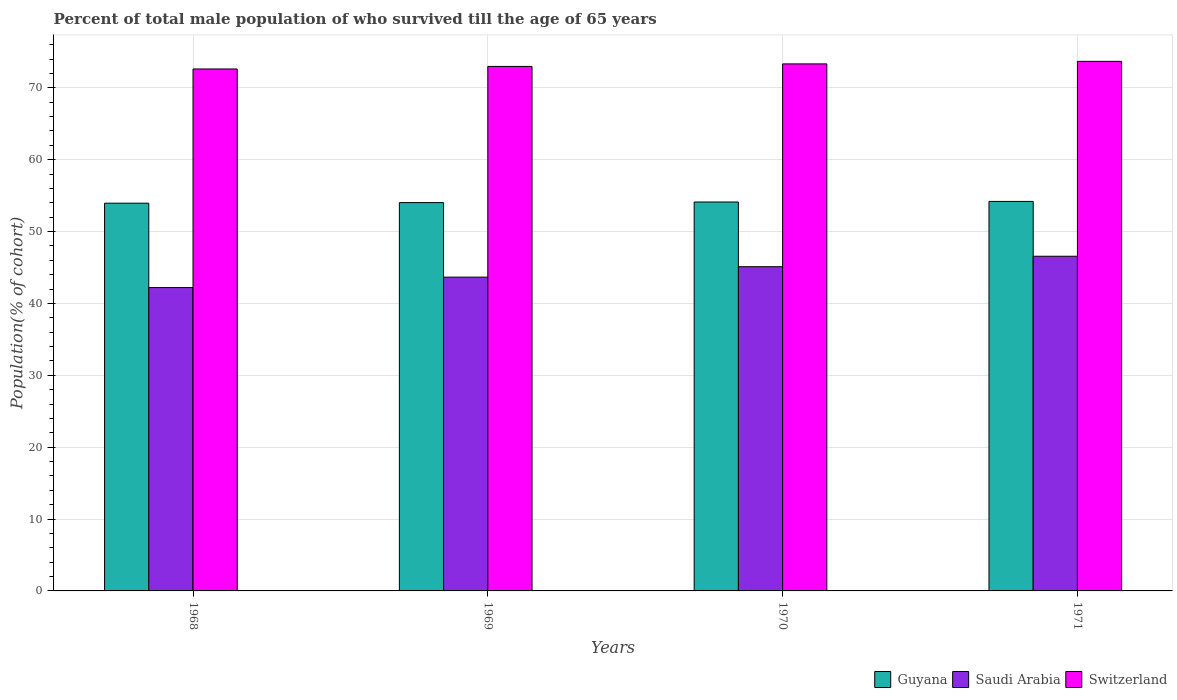Are the number of bars per tick equal to the number of legend labels?
Provide a short and direct response. Yes. Are the number of bars on each tick of the X-axis equal?
Keep it short and to the point. Yes. What is the label of the 2nd group of bars from the left?
Give a very brief answer. 1969. In how many cases, is the number of bars for a given year not equal to the number of legend labels?
Ensure brevity in your answer.  0. What is the percentage of total male population who survived till the age of 65 years in Switzerland in 1971?
Provide a succinct answer. 73.69. Across all years, what is the maximum percentage of total male population who survived till the age of 65 years in Switzerland?
Keep it short and to the point. 73.69. Across all years, what is the minimum percentage of total male population who survived till the age of 65 years in Guyana?
Your answer should be compact. 53.95. In which year was the percentage of total male population who survived till the age of 65 years in Switzerland maximum?
Ensure brevity in your answer.  1971. In which year was the percentage of total male population who survived till the age of 65 years in Switzerland minimum?
Provide a short and direct response. 1968. What is the total percentage of total male population who survived till the age of 65 years in Switzerland in the graph?
Keep it short and to the point. 292.64. What is the difference between the percentage of total male population who survived till the age of 65 years in Guyana in 1969 and that in 1970?
Provide a short and direct response. -0.08. What is the difference between the percentage of total male population who survived till the age of 65 years in Switzerland in 1968 and the percentage of total male population who survived till the age of 65 years in Saudi Arabia in 1969?
Provide a succinct answer. 28.97. What is the average percentage of total male population who survived till the age of 65 years in Guyana per year?
Offer a very short reply. 54.08. In the year 1969, what is the difference between the percentage of total male population who survived till the age of 65 years in Switzerland and percentage of total male population who survived till the age of 65 years in Guyana?
Give a very brief answer. 18.95. What is the ratio of the percentage of total male population who survived till the age of 65 years in Switzerland in 1968 to that in 1969?
Your answer should be compact. 1. Is the difference between the percentage of total male population who survived till the age of 65 years in Switzerland in 1968 and 1970 greater than the difference between the percentage of total male population who survived till the age of 65 years in Guyana in 1968 and 1970?
Provide a short and direct response. No. What is the difference between the highest and the second highest percentage of total male population who survived till the age of 65 years in Switzerland?
Your response must be concise. 0.35. What is the difference between the highest and the lowest percentage of total male population who survived till the age of 65 years in Guyana?
Your answer should be very brief. 0.25. In how many years, is the percentage of total male population who survived till the age of 65 years in Guyana greater than the average percentage of total male population who survived till the age of 65 years in Guyana taken over all years?
Make the answer very short. 2. What does the 1st bar from the left in 1970 represents?
Make the answer very short. Guyana. What does the 2nd bar from the right in 1968 represents?
Ensure brevity in your answer.  Saudi Arabia. How many bars are there?
Provide a succinct answer. 12. Are all the bars in the graph horizontal?
Make the answer very short. No. Are the values on the major ticks of Y-axis written in scientific E-notation?
Give a very brief answer. No. Does the graph contain any zero values?
Offer a very short reply. No. Does the graph contain grids?
Your answer should be compact. Yes. How many legend labels are there?
Ensure brevity in your answer.  3. What is the title of the graph?
Your response must be concise. Percent of total male population of who survived till the age of 65 years. What is the label or title of the X-axis?
Offer a very short reply. Years. What is the label or title of the Y-axis?
Your response must be concise. Population(% of cohort). What is the Population(% of cohort) of Guyana in 1968?
Ensure brevity in your answer.  53.95. What is the Population(% of cohort) in Saudi Arabia in 1968?
Your response must be concise. 42.21. What is the Population(% of cohort) of Switzerland in 1968?
Make the answer very short. 72.63. What is the Population(% of cohort) in Guyana in 1969?
Offer a very short reply. 54.04. What is the Population(% of cohort) in Saudi Arabia in 1969?
Ensure brevity in your answer.  43.66. What is the Population(% of cohort) in Switzerland in 1969?
Offer a terse response. 72.98. What is the Population(% of cohort) of Guyana in 1970?
Give a very brief answer. 54.12. What is the Population(% of cohort) of Saudi Arabia in 1970?
Give a very brief answer. 45.12. What is the Population(% of cohort) in Switzerland in 1970?
Provide a short and direct response. 73.34. What is the Population(% of cohort) of Guyana in 1971?
Ensure brevity in your answer.  54.2. What is the Population(% of cohort) in Saudi Arabia in 1971?
Offer a very short reply. 46.57. What is the Population(% of cohort) in Switzerland in 1971?
Offer a terse response. 73.69. Across all years, what is the maximum Population(% of cohort) of Guyana?
Your answer should be compact. 54.2. Across all years, what is the maximum Population(% of cohort) of Saudi Arabia?
Give a very brief answer. 46.57. Across all years, what is the maximum Population(% of cohort) of Switzerland?
Provide a short and direct response. 73.69. Across all years, what is the minimum Population(% of cohort) of Guyana?
Offer a terse response. 53.95. Across all years, what is the minimum Population(% of cohort) of Saudi Arabia?
Your response must be concise. 42.21. Across all years, what is the minimum Population(% of cohort) in Switzerland?
Your response must be concise. 72.63. What is the total Population(% of cohort) of Guyana in the graph?
Keep it short and to the point. 216.31. What is the total Population(% of cohort) in Saudi Arabia in the graph?
Your answer should be very brief. 177.56. What is the total Population(% of cohort) in Switzerland in the graph?
Give a very brief answer. 292.64. What is the difference between the Population(% of cohort) in Guyana in 1968 and that in 1969?
Your response must be concise. -0.08. What is the difference between the Population(% of cohort) in Saudi Arabia in 1968 and that in 1969?
Offer a very short reply. -1.45. What is the difference between the Population(% of cohort) in Switzerland in 1968 and that in 1969?
Offer a very short reply. -0.35. What is the difference between the Population(% of cohort) in Guyana in 1968 and that in 1970?
Ensure brevity in your answer.  -0.16. What is the difference between the Population(% of cohort) in Saudi Arabia in 1968 and that in 1970?
Keep it short and to the point. -2.91. What is the difference between the Population(% of cohort) in Switzerland in 1968 and that in 1970?
Offer a very short reply. -0.71. What is the difference between the Population(% of cohort) in Guyana in 1968 and that in 1971?
Your answer should be compact. -0.24. What is the difference between the Population(% of cohort) in Saudi Arabia in 1968 and that in 1971?
Offer a very short reply. -4.36. What is the difference between the Population(% of cohort) in Switzerland in 1968 and that in 1971?
Your answer should be compact. -1.06. What is the difference between the Population(% of cohort) of Guyana in 1969 and that in 1970?
Your answer should be very brief. -0.08. What is the difference between the Population(% of cohort) of Saudi Arabia in 1969 and that in 1970?
Provide a short and direct response. -1.45. What is the difference between the Population(% of cohort) of Switzerland in 1969 and that in 1970?
Your answer should be very brief. -0.35. What is the difference between the Population(% of cohort) of Guyana in 1969 and that in 1971?
Give a very brief answer. -0.16. What is the difference between the Population(% of cohort) of Saudi Arabia in 1969 and that in 1971?
Provide a short and direct response. -2.91. What is the difference between the Population(% of cohort) of Switzerland in 1969 and that in 1971?
Make the answer very short. -0.71. What is the difference between the Population(% of cohort) of Guyana in 1970 and that in 1971?
Offer a terse response. -0.08. What is the difference between the Population(% of cohort) of Saudi Arabia in 1970 and that in 1971?
Provide a succinct answer. -1.45. What is the difference between the Population(% of cohort) of Switzerland in 1970 and that in 1971?
Give a very brief answer. -0.35. What is the difference between the Population(% of cohort) in Guyana in 1968 and the Population(% of cohort) in Saudi Arabia in 1969?
Give a very brief answer. 10.29. What is the difference between the Population(% of cohort) in Guyana in 1968 and the Population(% of cohort) in Switzerland in 1969?
Offer a very short reply. -19.03. What is the difference between the Population(% of cohort) in Saudi Arabia in 1968 and the Population(% of cohort) in Switzerland in 1969?
Keep it short and to the point. -30.77. What is the difference between the Population(% of cohort) in Guyana in 1968 and the Population(% of cohort) in Saudi Arabia in 1970?
Offer a terse response. 8.84. What is the difference between the Population(% of cohort) in Guyana in 1968 and the Population(% of cohort) in Switzerland in 1970?
Your answer should be compact. -19.38. What is the difference between the Population(% of cohort) of Saudi Arabia in 1968 and the Population(% of cohort) of Switzerland in 1970?
Provide a succinct answer. -31.13. What is the difference between the Population(% of cohort) in Guyana in 1968 and the Population(% of cohort) in Saudi Arabia in 1971?
Make the answer very short. 7.38. What is the difference between the Population(% of cohort) in Guyana in 1968 and the Population(% of cohort) in Switzerland in 1971?
Provide a short and direct response. -19.74. What is the difference between the Population(% of cohort) in Saudi Arabia in 1968 and the Population(% of cohort) in Switzerland in 1971?
Your answer should be compact. -31.48. What is the difference between the Population(% of cohort) of Guyana in 1969 and the Population(% of cohort) of Saudi Arabia in 1970?
Your response must be concise. 8.92. What is the difference between the Population(% of cohort) of Guyana in 1969 and the Population(% of cohort) of Switzerland in 1970?
Ensure brevity in your answer.  -19.3. What is the difference between the Population(% of cohort) of Saudi Arabia in 1969 and the Population(% of cohort) of Switzerland in 1970?
Provide a short and direct response. -29.67. What is the difference between the Population(% of cohort) of Guyana in 1969 and the Population(% of cohort) of Saudi Arabia in 1971?
Provide a succinct answer. 7.47. What is the difference between the Population(% of cohort) of Guyana in 1969 and the Population(% of cohort) of Switzerland in 1971?
Your answer should be compact. -19.65. What is the difference between the Population(% of cohort) in Saudi Arabia in 1969 and the Population(% of cohort) in Switzerland in 1971?
Your answer should be compact. -30.03. What is the difference between the Population(% of cohort) of Guyana in 1970 and the Population(% of cohort) of Saudi Arabia in 1971?
Provide a short and direct response. 7.55. What is the difference between the Population(% of cohort) in Guyana in 1970 and the Population(% of cohort) in Switzerland in 1971?
Your answer should be very brief. -19.57. What is the difference between the Population(% of cohort) of Saudi Arabia in 1970 and the Population(% of cohort) of Switzerland in 1971?
Provide a short and direct response. -28.57. What is the average Population(% of cohort) in Guyana per year?
Your response must be concise. 54.08. What is the average Population(% of cohort) of Saudi Arabia per year?
Give a very brief answer. 44.39. What is the average Population(% of cohort) in Switzerland per year?
Ensure brevity in your answer.  73.16. In the year 1968, what is the difference between the Population(% of cohort) in Guyana and Population(% of cohort) in Saudi Arabia?
Make the answer very short. 11.74. In the year 1968, what is the difference between the Population(% of cohort) in Guyana and Population(% of cohort) in Switzerland?
Offer a terse response. -18.67. In the year 1968, what is the difference between the Population(% of cohort) of Saudi Arabia and Population(% of cohort) of Switzerland?
Offer a very short reply. -30.42. In the year 1969, what is the difference between the Population(% of cohort) in Guyana and Population(% of cohort) in Saudi Arabia?
Ensure brevity in your answer.  10.37. In the year 1969, what is the difference between the Population(% of cohort) in Guyana and Population(% of cohort) in Switzerland?
Offer a very short reply. -18.95. In the year 1969, what is the difference between the Population(% of cohort) in Saudi Arabia and Population(% of cohort) in Switzerland?
Offer a terse response. -29.32. In the year 1970, what is the difference between the Population(% of cohort) of Guyana and Population(% of cohort) of Saudi Arabia?
Ensure brevity in your answer.  9. In the year 1970, what is the difference between the Population(% of cohort) in Guyana and Population(% of cohort) in Switzerland?
Provide a short and direct response. -19.22. In the year 1970, what is the difference between the Population(% of cohort) of Saudi Arabia and Population(% of cohort) of Switzerland?
Ensure brevity in your answer.  -28.22. In the year 1971, what is the difference between the Population(% of cohort) in Guyana and Population(% of cohort) in Saudi Arabia?
Your answer should be very brief. 7.63. In the year 1971, what is the difference between the Population(% of cohort) of Guyana and Population(% of cohort) of Switzerland?
Your answer should be compact. -19.49. In the year 1971, what is the difference between the Population(% of cohort) of Saudi Arabia and Population(% of cohort) of Switzerland?
Offer a terse response. -27.12. What is the ratio of the Population(% of cohort) of Saudi Arabia in 1968 to that in 1969?
Give a very brief answer. 0.97. What is the ratio of the Population(% of cohort) in Switzerland in 1968 to that in 1969?
Your response must be concise. 1. What is the ratio of the Population(% of cohort) of Guyana in 1968 to that in 1970?
Your response must be concise. 1. What is the ratio of the Population(% of cohort) of Saudi Arabia in 1968 to that in 1970?
Provide a short and direct response. 0.94. What is the ratio of the Population(% of cohort) in Guyana in 1968 to that in 1971?
Your answer should be compact. 1. What is the ratio of the Population(% of cohort) of Saudi Arabia in 1968 to that in 1971?
Make the answer very short. 0.91. What is the ratio of the Population(% of cohort) in Switzerland in 1968 to that in 1971?
Your response must be concise. 0.99. What is the ratio of the Population(% of cohort) of Guyana in 1969 to that in 1970?
Offer a terse response. 1. What is the ratio of the Population(% of cohort) of Saudi Arabia in 1969 to that in 1970?
Ensure brevity in your answer.  0.97. What is the ratio of the Population(% of cohort) in Switzerland in 1969 to that in 1970?
Keep it short and to the point. 1. What is the ratio of the Population(% of cohort) in Saudi Arabia in 1969 to that in 1971?
Offer a terse response. 0.94. What is the ratio of the Population(% of cohort) in Saudi Arabia in 1970 to that in 1971?
Your answer should be compact. 0.97. What is the ratio of the Population(% of cohort) of Switzerland in 1970 to that in 1971?
Offer a very short reply. 1. What is the difference between the highest and the second highest Population(% of cohort) in Guyana?
Offer a very short reply. 0.08. What is the difference between the highest and the second highest Population(% of cohort) of Saudi Arabia?
Offer a terse response. 1.45. What is the difference between the highest and the second highest Population(% of cohort) of Switzerland?
Provide a short and direct response. 0.35. What is the difference between the highest and the lowest Population(% of cohort) in Guyana?
Keep it short and to the point. 0.24. What is the difference between the highest and the lowest Population(% of cohort) of Saudi Arabia?
Offer a terse response. 4.36. What is the difference between the highest and the lowest Population(% of cohort) of Switzerland?
Give a very brief answer. 1.06. 